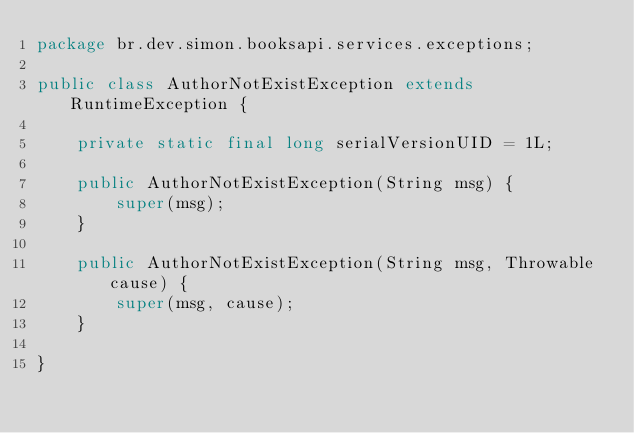Convert code to text. <code><loc_0><loc_0><loc_500><loc_500><_Java_>package br.dev.simon.booksapi.services.exceptions;

public class AuthorNotExistException extends RuntimeException {

	private static final long serialVersionUID = 1L;

	public AuthorNotExistException(String msg) {
		super(msg);
	}

	public AuthorNotExistException(String msg, Throwable cause) {
		super(msg, cause);
	}

}
</code> 